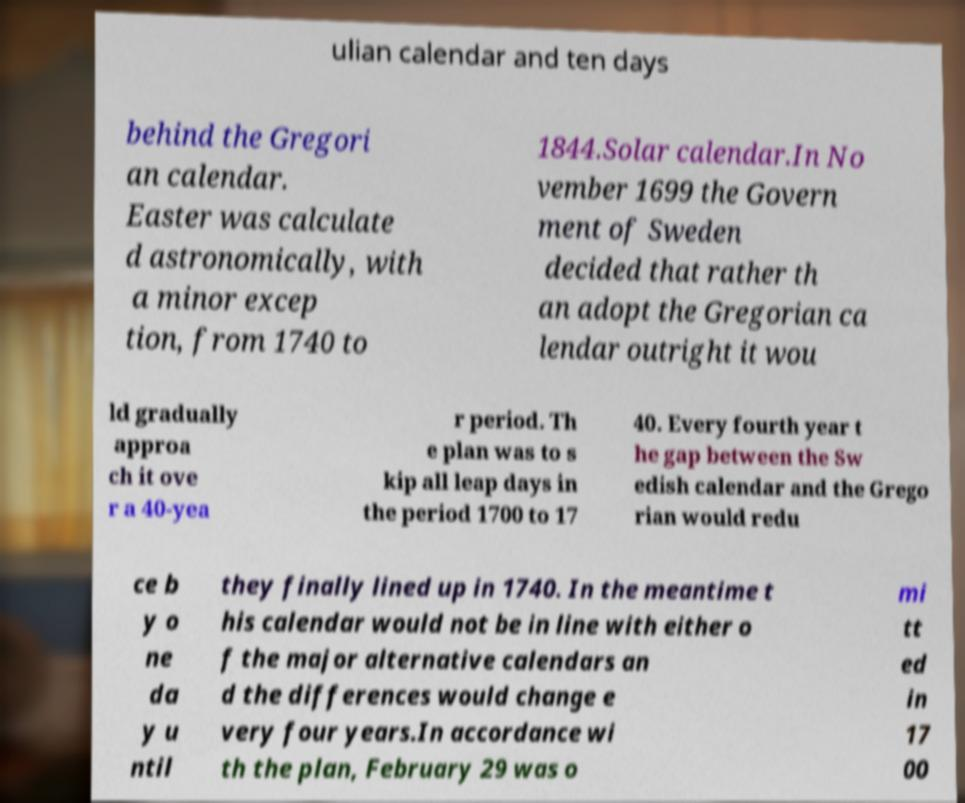Could you extract and type out the text from this image? ulian calendar and ten days behind the Gregori an calendar. Easter was calculate d astronomically, with a minor excep tion, from 1740 to 1844.Solar calendar.In No vember 1699 the Govern ment of Sweden decided that rather th an adopt the Gregorian ca lendar outright it wou ld gradually approa ch it ove r a 40-yea r period. Th e plan was to s kip all leap days in the period 1700 to 17 40. Every fourth year t he gap between the Sw edish calendar and the Grego rian would redu ce b y o ne da y u ntil they finally lined up in 1740. In the meantime t his calendar would not be in line with either o f the major alternative calendars an d the differences would change e very four years.In accordance wi th the plan, February 29 was o mi tt ed in 17 00 